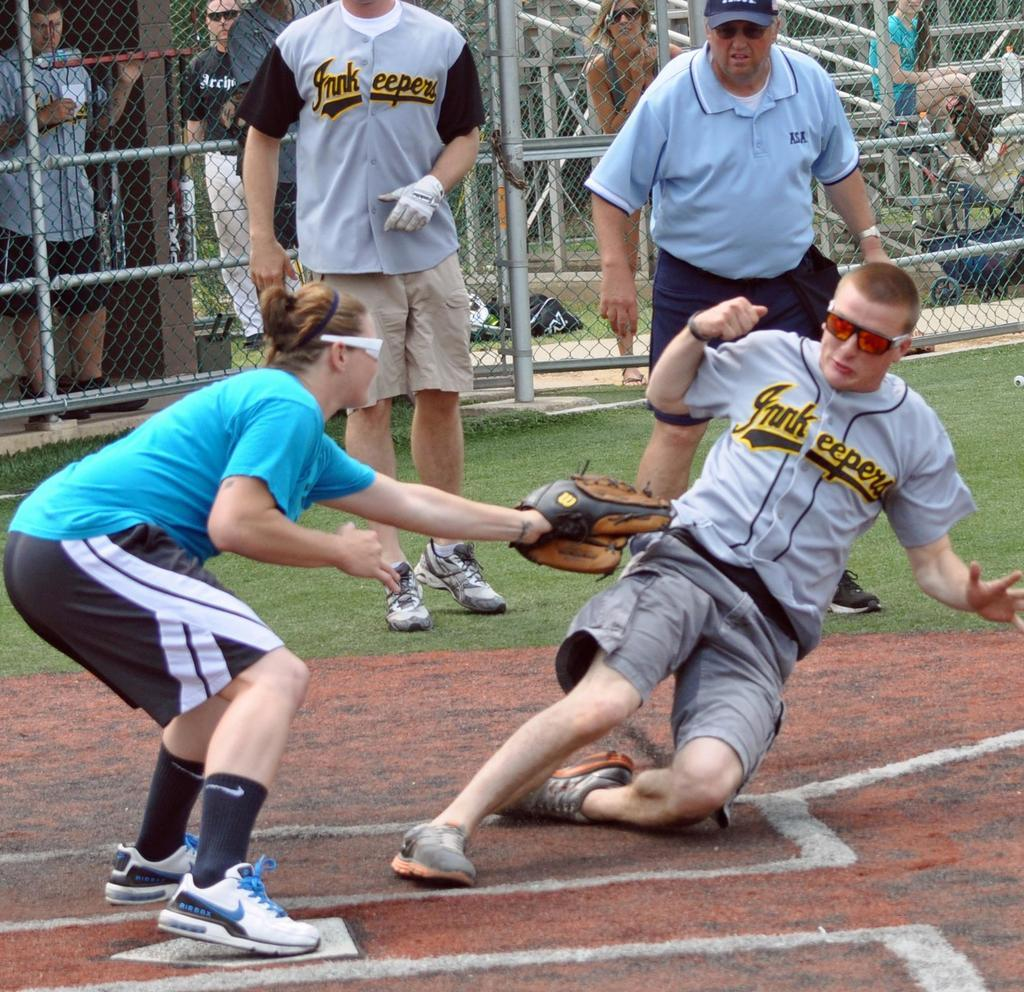How many people are actively participating in the activity in the image? There are four people playing in the image. Can you describe the people in the background of the image? There are people standing in the background of the image. What type of barrier is present at the backside of the image? Fencing is done at the backside of the image. What is the fireman doing in the image? There is no fireman present in the image. What is the chance of winning the game for the players in the image? The image does not provide information about the chances of winning the game for the players. 